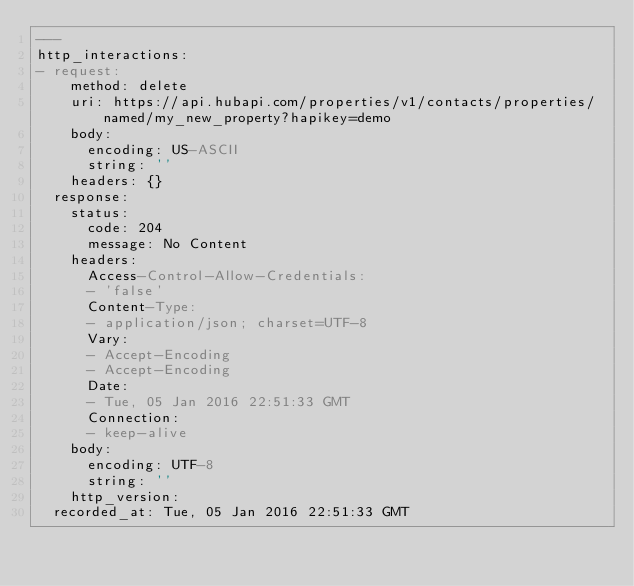Convert code to text. <code><loc_0><loc_0><loc_500><loc_500><_YAML_>---
http_interactions:
- request:
    method: delete
    uri: https://api.hubapi.com/properties/v1/contacts/properties/named/my_new_property?hapikey=demo
    body:
      encoding: US-ASCII
      string: ''
    headers: {}
  response:
    status:
      code: 204
      message: No Content
    headers:
      Access-Control-Allow-Credentials:
      - 'false'
      Content-Type:
      - application/json; charset=UTF-8
      Vary:
      - Accept-Encoding
      - Accept-Encoding
      Date:
      - Tue, 05 Jan 2016 22:51:33 GMT
      Connection:
      - keep-alive
    body:
      encoding: UTF-8
      string: ''
    http_version: 
  recorded_at: Tue, 05 Jan 2016 22:51:33 GMT
</code> 